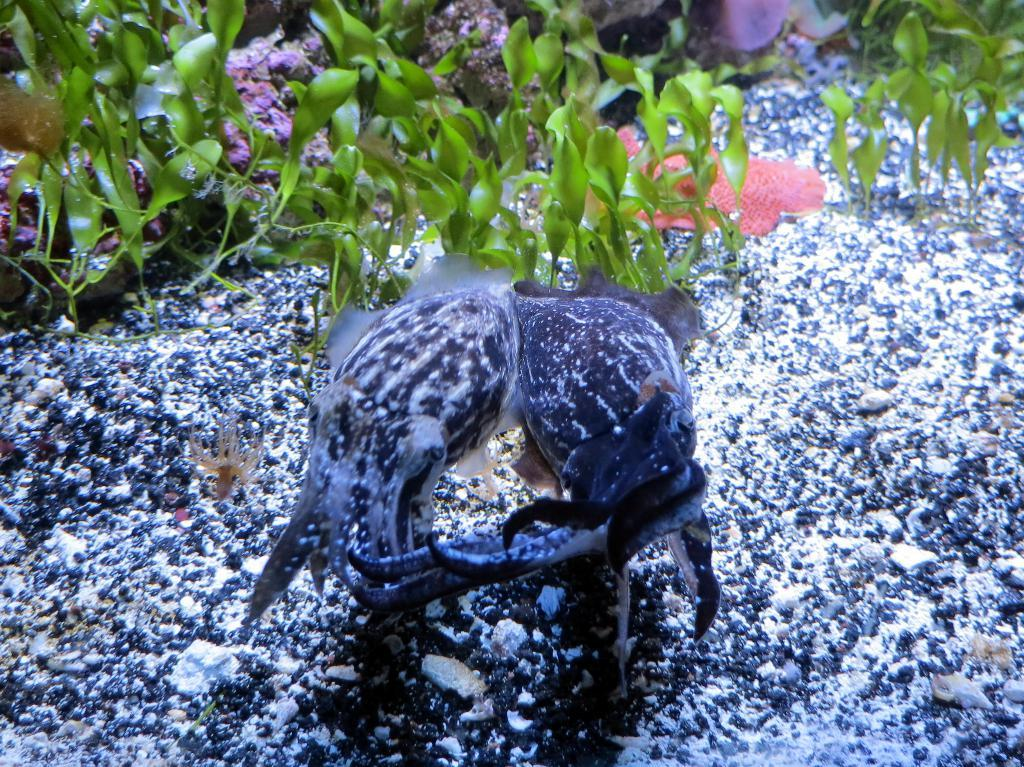What type of living organisms can be seen in the image? There are water animals in the image. What other elements can be seen in the image besides the water animals? There are plants in the image. Where is the river located in the image? There is no river present in the image. What type of brush can be seen in the image? There is no brush present in the image. 